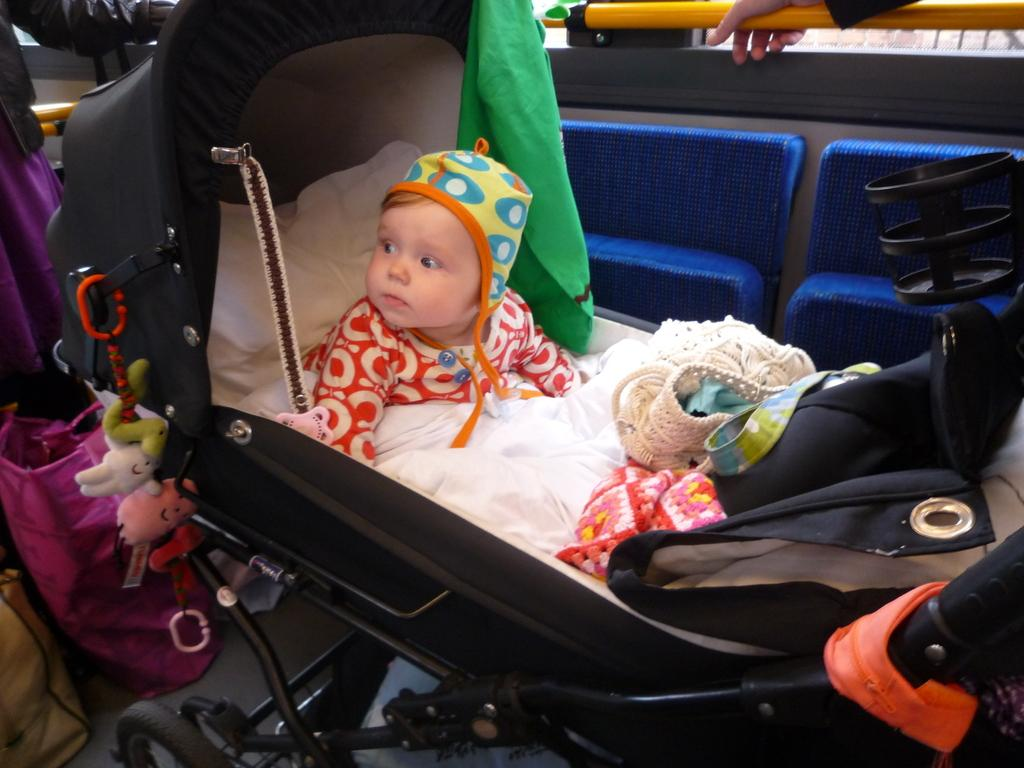What is the main subject of the image? There is a baby in the image. What is the baby wearing? The baby is wearing a cap. What is the baby sitting on? The baby is sitting on a wheelchair. Can you describe the person in the background of the image? The person in the background is holding a yellow color rod. What else can be seen in the background of the image? There are other objects in the background. How many women are present in the image? There is no mention of any women in the image; it features a baby and a person in the background. What type of metal is the zinc rod made of in the image? There is no mention of a zinc rod in the image; the person in the background is holding a yellow color rod, but the material is not specified. 